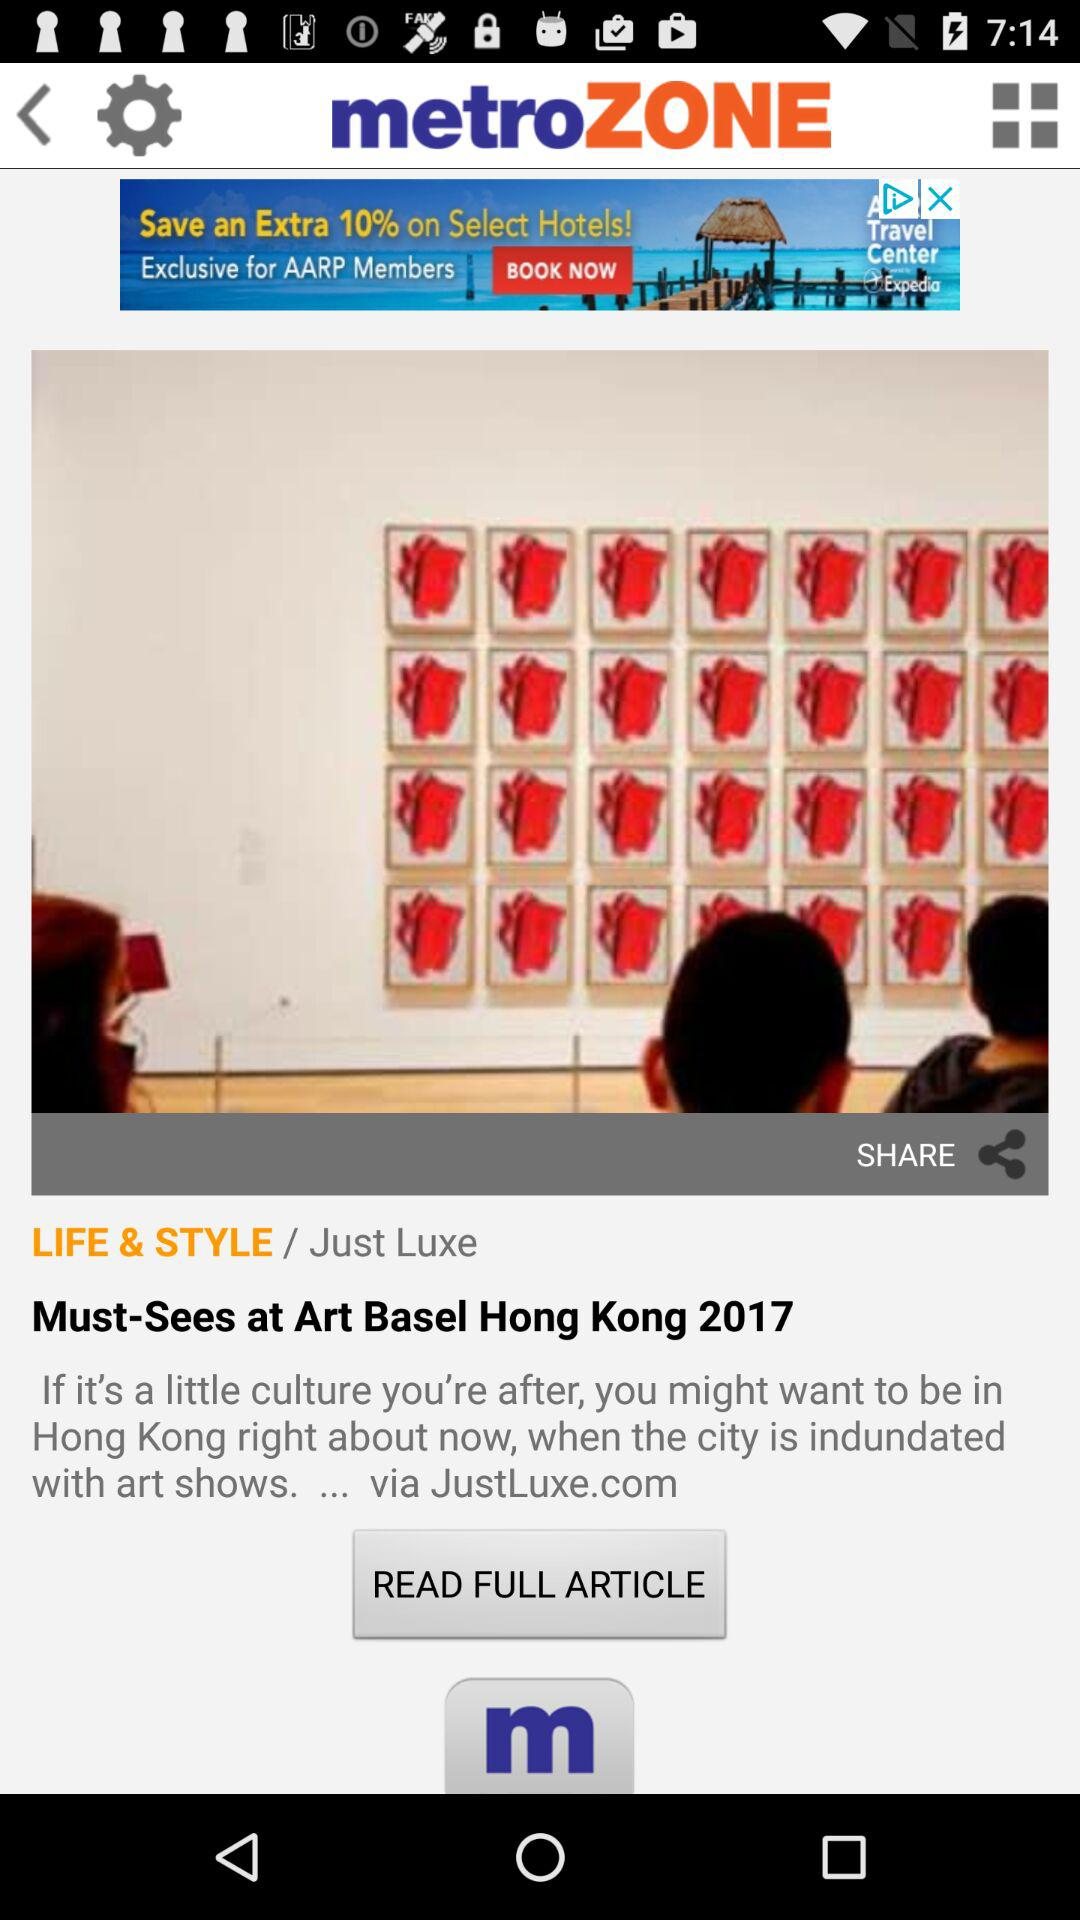How old is the user?
When the provided information is insufficient, respond with <no answer>. <no answer> 